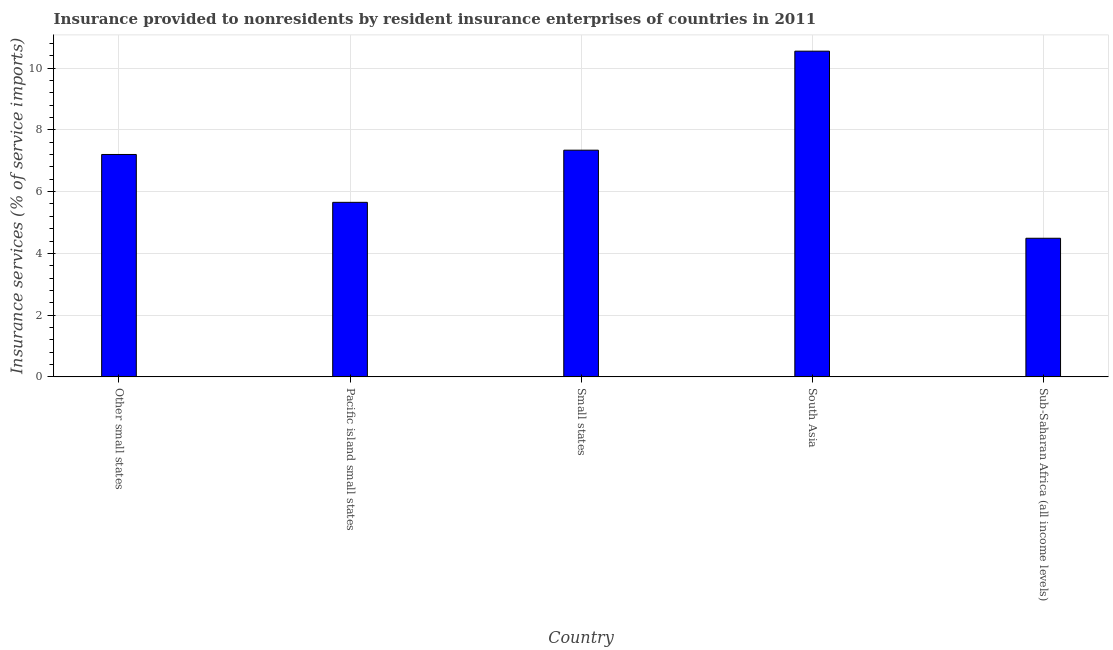What is the title of the graph?
Provide a succinct answer. Insurance provided to nonresidents by resident insurance enterprises of countries in 2011. What is the label or title of the X-axis?
Offer a very short reply. Country. What is the label or title of the Y-axis?
Offer a terse response. Insurance services (% of service imports). What is the insurance and financial services in Pacific island small states?
Your response must be concise. 5.65. Across all countries, what is the maximum insurance and financial services?
Give a very brief answer. 10.55. Across all countries, what is the minimum insurance and financial services?
Offer a very short reply. 4.49. In which country was the insurance and financial services maximum?
Your answer should be very brief. South Asia. In which country was the insurance and financial services minimum?
Keep it short and to the point. Sub-Saharan Africa (all income levels). What is the sum of the insurance and financial services?
Make the answer very short. 35.24. What is the difference between the insurance and financial services in Pacific island small states and South Asia?
Provide a succinct answer. -4.9. What is the average insurance and financial services per country?
Ensure brevity in your answer.  7.05. What is the median insurance and financial services?
Offer a terse response. 7.2. What is the ratio of the insurance and financial services in Small states to that in South Asia?
Offer a terse response. 0.7. What is the difference between the highest and the second highest insurance and financial services?
Ensure brevity in your answer.  3.21. Is the sum of the insurance and financial services in Other small states and Sub-Saharan Africa (all income levels) greater than the maximum insurance and financial services across all countries?
Offer a very short reply. Yes. What is the difference between the highest and the lowest insurance and financial services?
Ensure brevity in your answer.  6.06. In how many countries, is the insurance and financial services greater than the average insurance and financial services taken over all countries?
Your answer should be very brief. 3. Are all the bars in the graph horizontal?
Make the answer very short. No. What is the difference between two consecutive major ticks on the Y-axis?
Your answer should be very brief. 2. What is the Insurance services (% of service imports) in Other small states?
Offer a terse response. 7.2. What is the Insurance services (% of service imports) in Pacific island small states?
Make the answer very short. 5.65. What is the Insurance services (% of service imports) in Small states?
Make the answer very short. 7.34. What is the Insurance services (% of service imports) of South Asia?
Your answer should be compact. 10.55. What is the Insurance services (% of service imports) in Sub-Saharan Africa (all income levels)?
Offer a terse response. 4.49. What is the difference between the Insurance services (% of service imports) in Other small states and Pacific island small states?
Offer a terse response. 1.55. What is the difference between the Insurance services (% of service imports) in Other small states and Small states?
Offer a very short reply. -0.14. What is the difference between the Insurance services (% of service imports) in Other small states and South Asia?
Keep it short and to the point. -3.35. What is the difference between the Insurance services (% of service imports) in Other small states and Sub-Saharan Africa (all income levels)?
Give a very brief answer. 2.71. What is the difference between the Insurance services (% of service imports) in Pacific island small states and Small states?
Make the answer very short. -1.69. What is the difference between the Insurance services (% of service imports) in Pacific island small states and South Asia?
Make the answer very short. -4.9. What is the difference between the Insurance services (% of service imports) in Pacific island small states and Sub-Saharan Africa (all income levels)?
Your response must be concise. 1.16. What is the difference between the Insurance services (% of service imports) in Small states and South Asia?
Your response must be concise. -3.21. What is the difference between the Insurance services (% of service imports) in Small states and Sub-Saharan Africa (all income levels)?
Your response must be concise. 2.85. What is the difference between the Insurance services (% of service imports) in South Asia and Sub-Saharan Africa (all income levels)?
Keep it short and to the point. 6.06. What is the ratio of the Insurance services (% of service imports) in Other small states to that in Pacific island small states?
Keep it short and to the point. 1.27. What is the ratio of the Insurance services (% of service imports) in Other small states to that in Small states?
Your response must be concise. 0.98. What is the ratio of the Insurance services (% of service imports) in Other small states to that in South Asia?
Your response must be concise. 0.68. What is the ratio of the Insurance services (% of service imports) in Other small states to that in Sub-Saharan Africa (all income levels)?
Your response must be concise. 1.6. What is the ratio of the Insurance services (% of service imports) in Pacific island small states to that in Small states?
Your answer should be compact. 0.77. What is the ratio of the Insurance services (% of service imports) in Pacific island small states to that in South Asia?
Provide a short and direct response. 0.54. What is the ratio of the Insurance services (% of service imports) in Pacific island small states to that in Sub-Saharan Africa (all income levels)?
Give a very brief answer. 1.26. What is the ratio of the Insurance services (% of service imports) in Small states to that in South Asia?
Offer a terse response. 0.7. What is the ratio of the Insurance services (% of service imports) in Small states to that in Sub-Saharan Africa (all income levels)?
Make the answer very short. 1.64. What is the ratio of the Insurance services (% of service imports) in South Asia to that in Sub-Saharan Africa (all income levels)?
Provide a succinct answer. 2.35. 